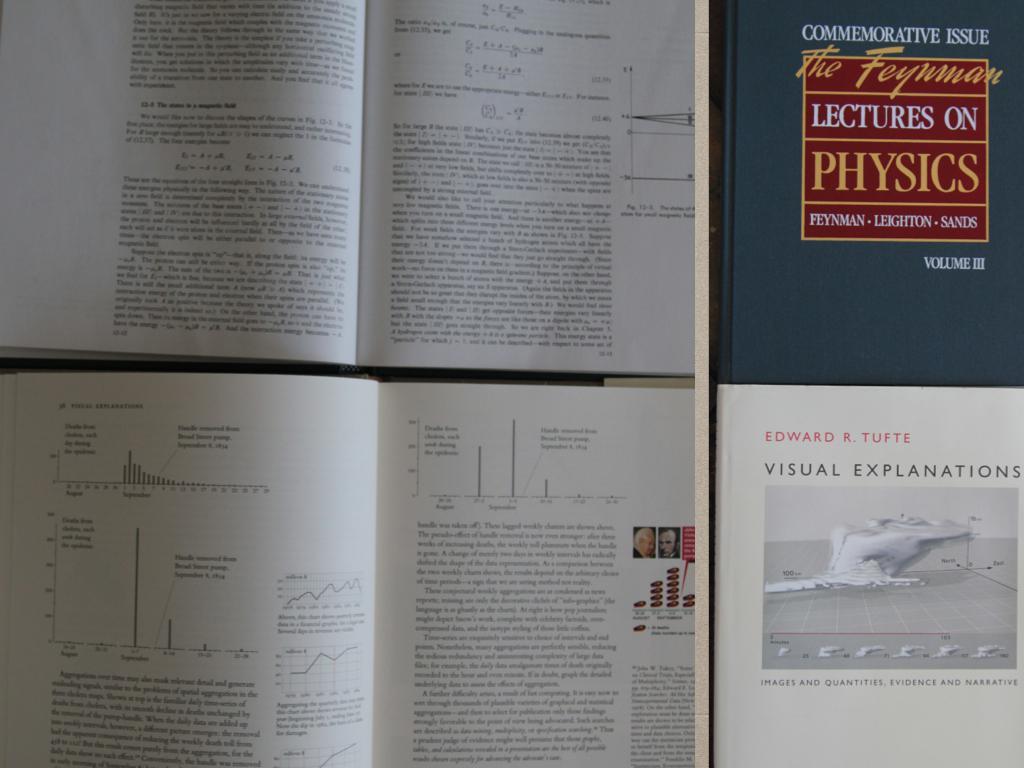Are these texts about physics?
Keep it short and to the point. Yes. Are these texts about law?
Your response must be concise. No. 